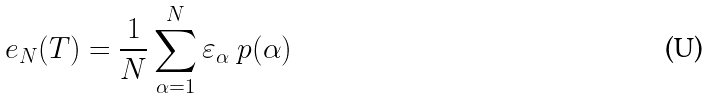<formula> <loc_0><loc_0><loc_500><loc_500>e _ { N } ( T ) = \frac { 1 } { N } \sum _ { \alpha = 1 } ^ { N } \varepsilon _ { \alpha } \ p ( \alpha )</formula> 